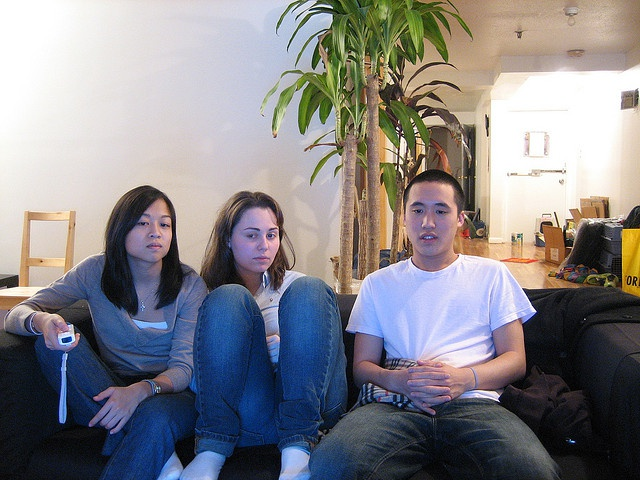Describe the objects in this image and their specific colors. I can see people in white, black, lavender, gray, and lightblue tones, potted plant in white, darkgreen, tan, gray, and darkgray tones, people in white, navy, blue, black, and darkblue tones, people in white, black, navy, and gray tones, and couch in white, black, gray, and navy tones in this image. 